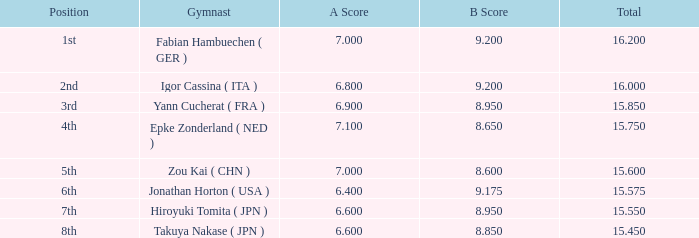Which gymnast had a b score of 8.95 and an a score less than 6.9 Hiroyuki Tomita ( JPN ). 